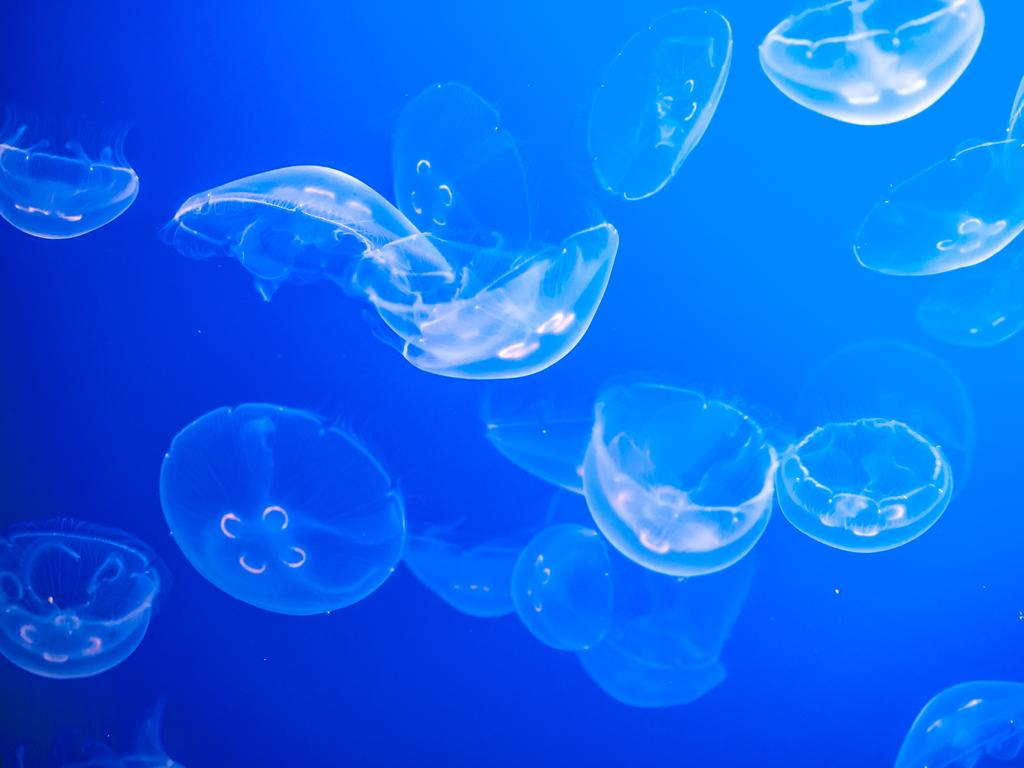What type of marine animals are present in the image? There are many Jellyfish in the image. Where are the Jellyfish located? The Jellyfish are underwater. What type of bird can be seen perched on the elbow in the image? There is no bird or elbow present in the image; it features Jellyfish underwater. 